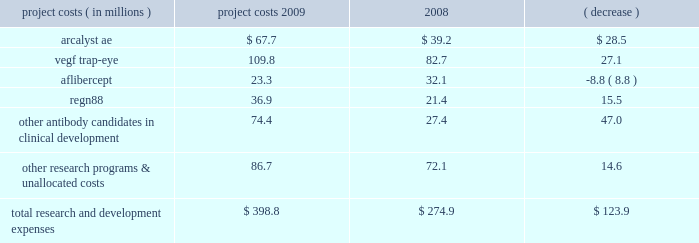We prepare estimates of research and development costs for projects in clinical development , which include direct costs and allocations of certain costs such as indirect labor , non-cash compensation expense , and manufacturing and other costs related to activities that benefit multiple projects , and , under our collaboration with bayer healthcare , the portion of bayer healthcare 2019s vegf trap-eye development expenses that we are obligated to reimburse .
Our estimates of research and development costs for clinical development programs are shown below : project costs year ended december 31 , increase ( decrease ) ( in millions ) 2009 2008 .
For the reasons described above in results of operations for the years ended december 31 , 2010 and 2009 , under the caption 201cresearch and development expenses 201d , and due to the variability in the costs necessary to develop a pharmaceutical product and the uncertainties related to future indications to be studied , the estimated cost and scope of the projects , and our ultimate ability to obtain governmental approval for commercialization , accurate and meaningful estimates of the total cost to bring our product candidates to market are not available .
Similarly , we are currently unable to reasonably estimate if our product candidates will generate material product revenues and net cash inflows .
In 2008 , we received fda approval for arcalyst ae for the treatment of caps , a group of rare , inherited auto-inflammatory diseases that affect a very small group of people .
We currently do not expect to generate material product revenues and net cash inflows from the sale of arcalyst ae for the treatment of caps .
Selling , general , and administrative expenses selling , general , and administrative expenses increased to $ 52.9 million in 2009 from $ 48.9 million in 2008 .
In 2009 , we incurred ( i ) higher compensation expense , ( ii ) higher patent-related costs , ( iii ) higher facility-related costs due primarily to increases in administrative headcount , and ( iv ) higher patient assistance costs related to arcalyst ae .
These increases were partly offset by ( i ) lower marketing costs related to arcalyst ae , ( ii ) a decrease in administrative recruitment costs , and ( iii ) lower professional fees related to various corporate matters .
Cost of goods sold during 2008 , we began recognizing revenue and cost of goods sold from net product sales of arcalyst ae .
Cost of goods sold in 2009 and 2008 was $ 1.7 million and $ 0.9 million , respectively , and consisted primarily of royalties and other period costs related to arcalyst ae commercial supplies .
In 2009 and 2008 , arcalyst ae shipments to our customers consisted of supplies of inventory manufactured and expensed as research and development costs prior to fda approval in 2008 ; therefore , the costs of these supplies were not included in costs of goods sold .
Other income and expense investment income decreased to $ 4.5 million in 2009 from $ 18.2 million in 2008 , due primarily to lower yields on , and lower balances of , cash and marketable securities .
In addition , in 2009 and 2008 , deterioration in the credit quality of specific marketable securities in our investment portfolio subjected us to the risk of not being able to recover these securities 2019 carrying values .
As a result , in 2009 and 2008 , we recognized charges of $ 0.1 million and $ 2.5 million , respectively , related to these securities , which we considered to be other than temporarily impaired .
In 2009 and 2008 , these charges were either wholly or partly offset by realized gains of $ 0.2 million and $ 1.2 million , respectively , on sales of marketable securities during the year. .
What was the percentage change in research and development costs related to arcalyst ae from 2008 to 2009? 
Computations: (28.5 / 39.2)
Answer: 0.72704. 